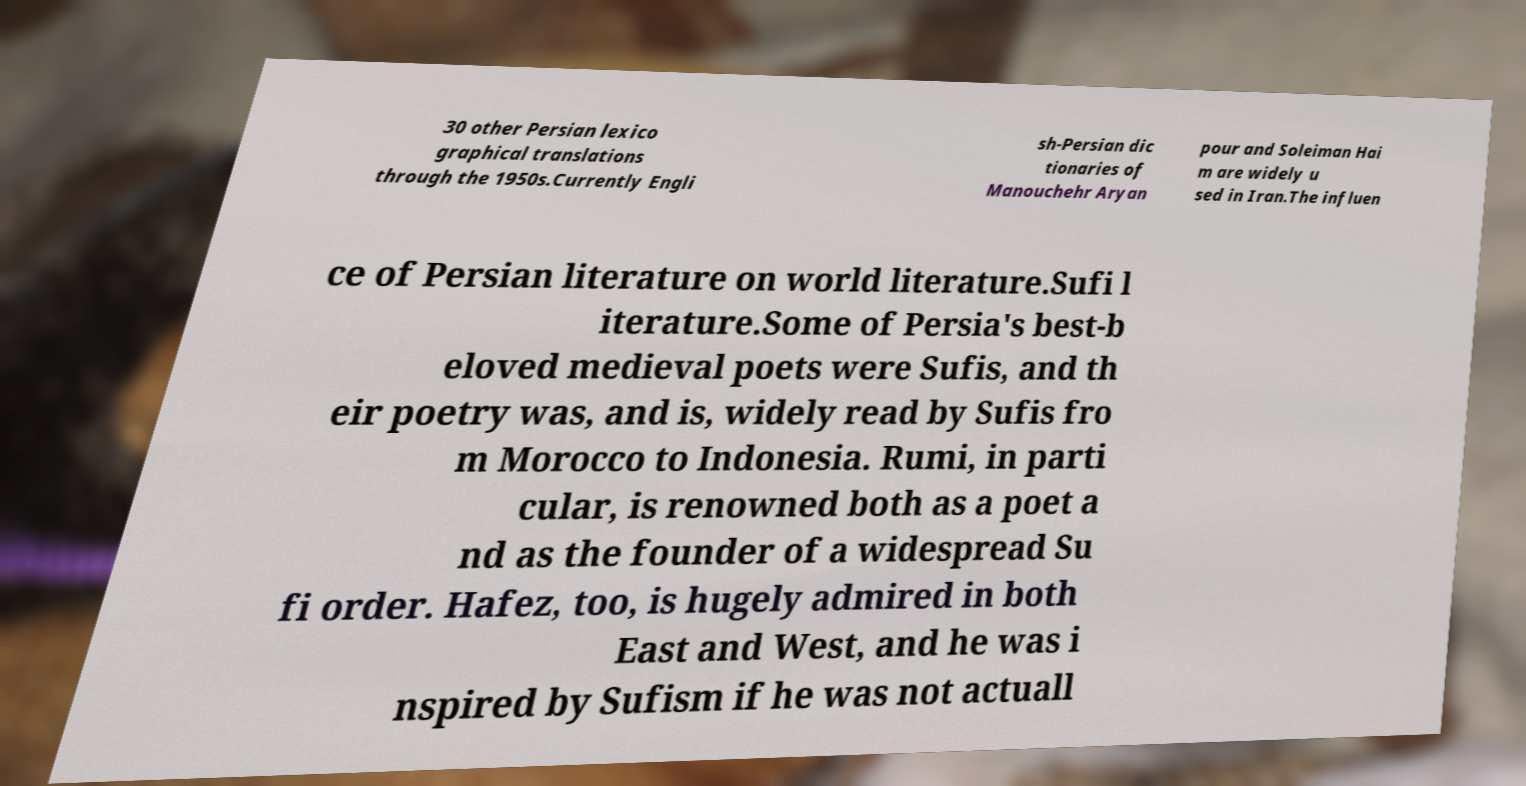Could you assist in decoding the text presented in this image and type it out clearly? 30 other Persian lexico graphical translations through the 1950s.Currently Engli sh-Persian dic tionaries of Manouchehr Aryan pour and Soleiman Hai m are widely u sed in Iran.The influen ce of Persian literature on world literature.Sufi l iterature.Some of Persia's best-b eloved medieval poets were Sufis, and th eir poetry was, and is, widely read by Sufis fro m Morocco to Indonesia. Rumi, in parti cular, is renowned both as a poet a nd as the founder of a widespread Su fi order. Hafez, too, is hugely admired in both East and West, and he was i nspired by Sufism if he was not actuall 